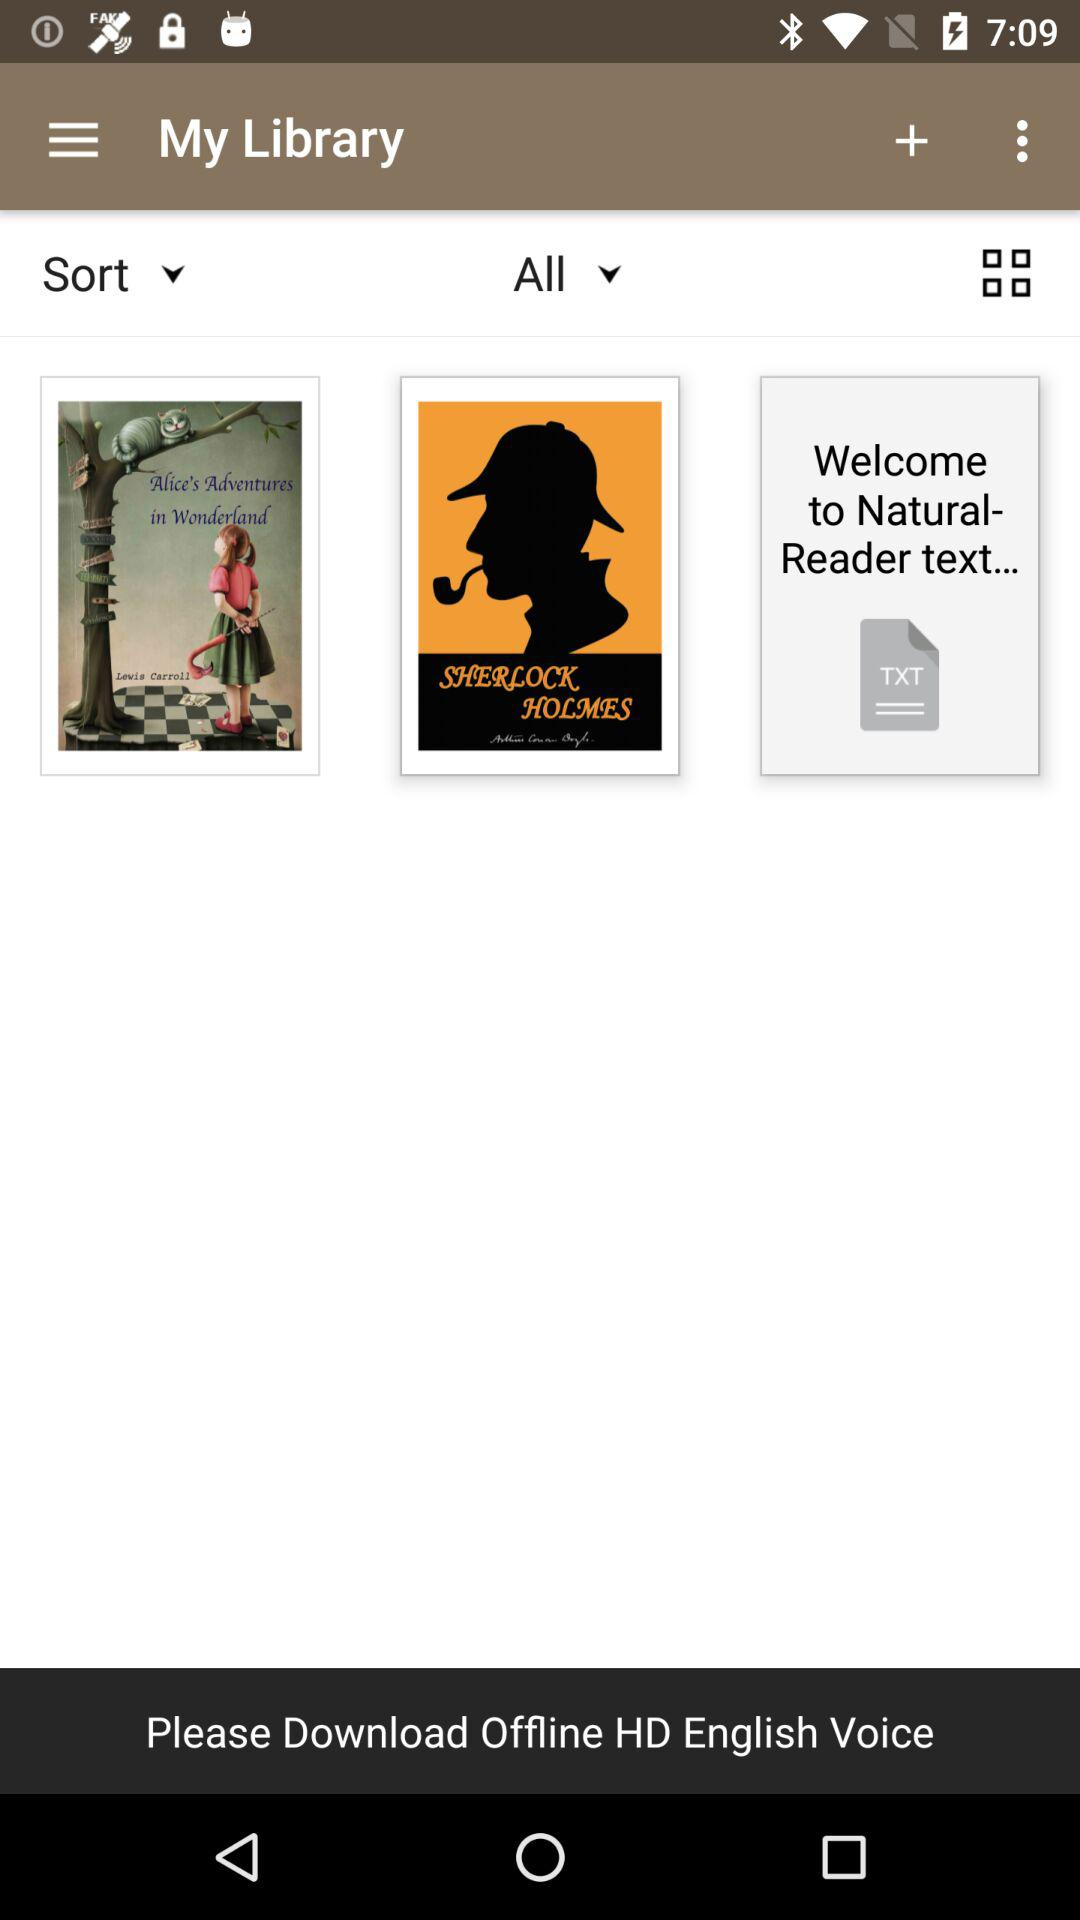What is the application name?
When the provided information is insufficient, respond with <no answer>. <no answer> 